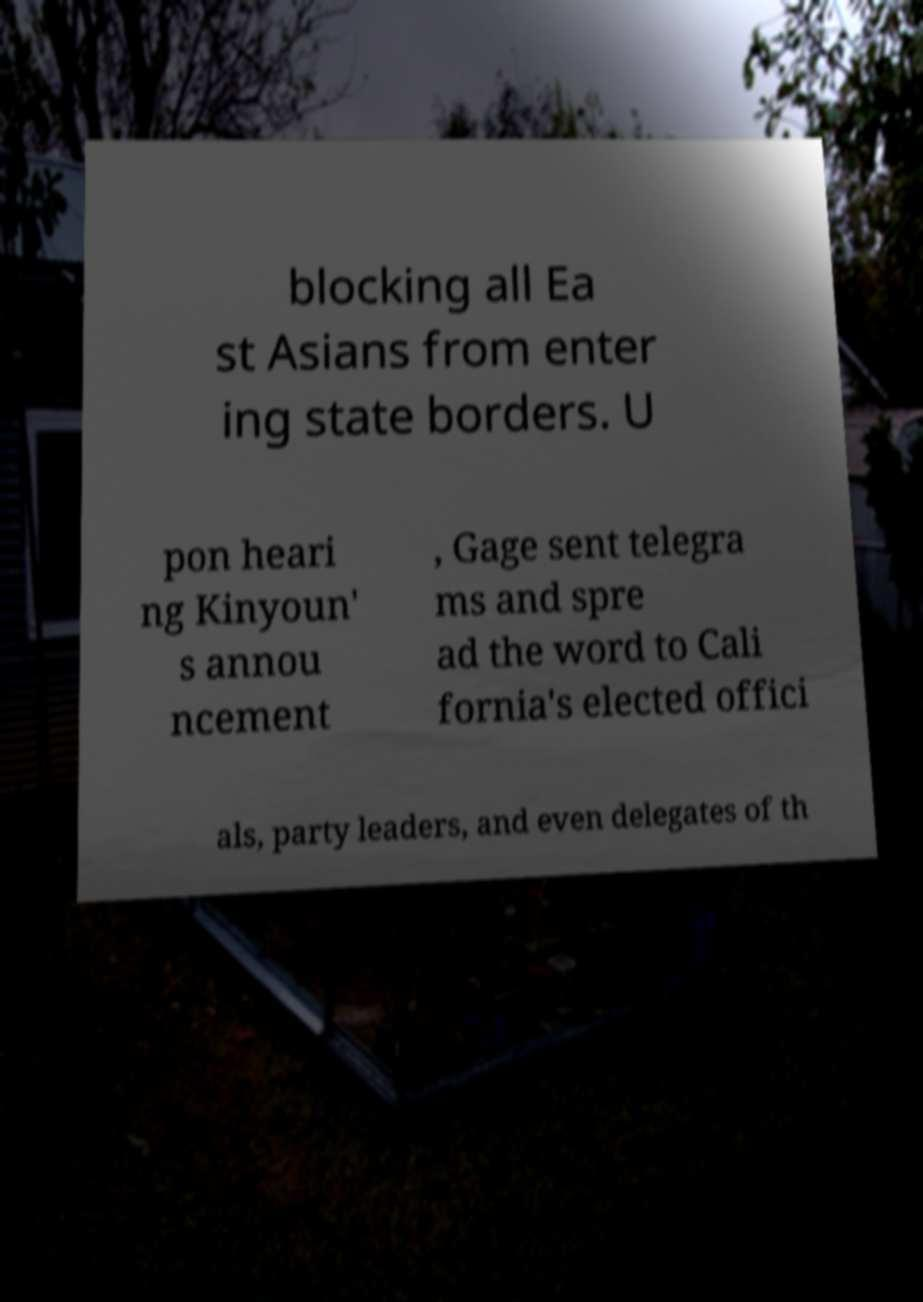Could you extract and type out the text from this image? blocking all Ea st Asians from enter ing state borders. U pon heari ng Kinyoun' s annou ncement , Gage sent telegra ms and spre ad the word to Cali fornia's elected offici als, party leaders, and even delegates of th 